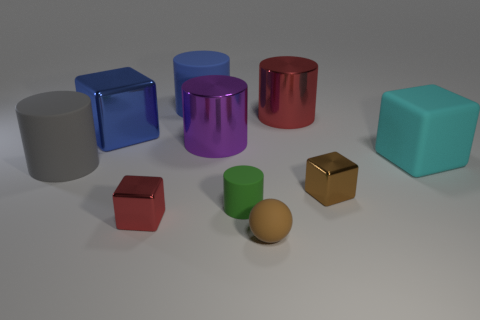Subtract all big matte cubes. How many cubes are left? 3 Subtract all cyan blocks. How many blocks are left? 3 Subtract all blocks. How many objects are left? 6 Subtract all gray matte cylinders. Subtract all purple shiny things. How many objects are left? 8 Add 8 blue cylinders. How many blue cylinders are left? 9 Add 5 large shiny blocks. How many large shiny blocks exist? 6 Subtract 1 cyan blocks. How many objects are left? 9 Subtract 1 balls. How many balls are left? 0 Subtract all yellow cylinders. Subtract all purple cubes. How many cylinders are left? 5 Subtract all purple cubes. How many green cylinders are left? 1 